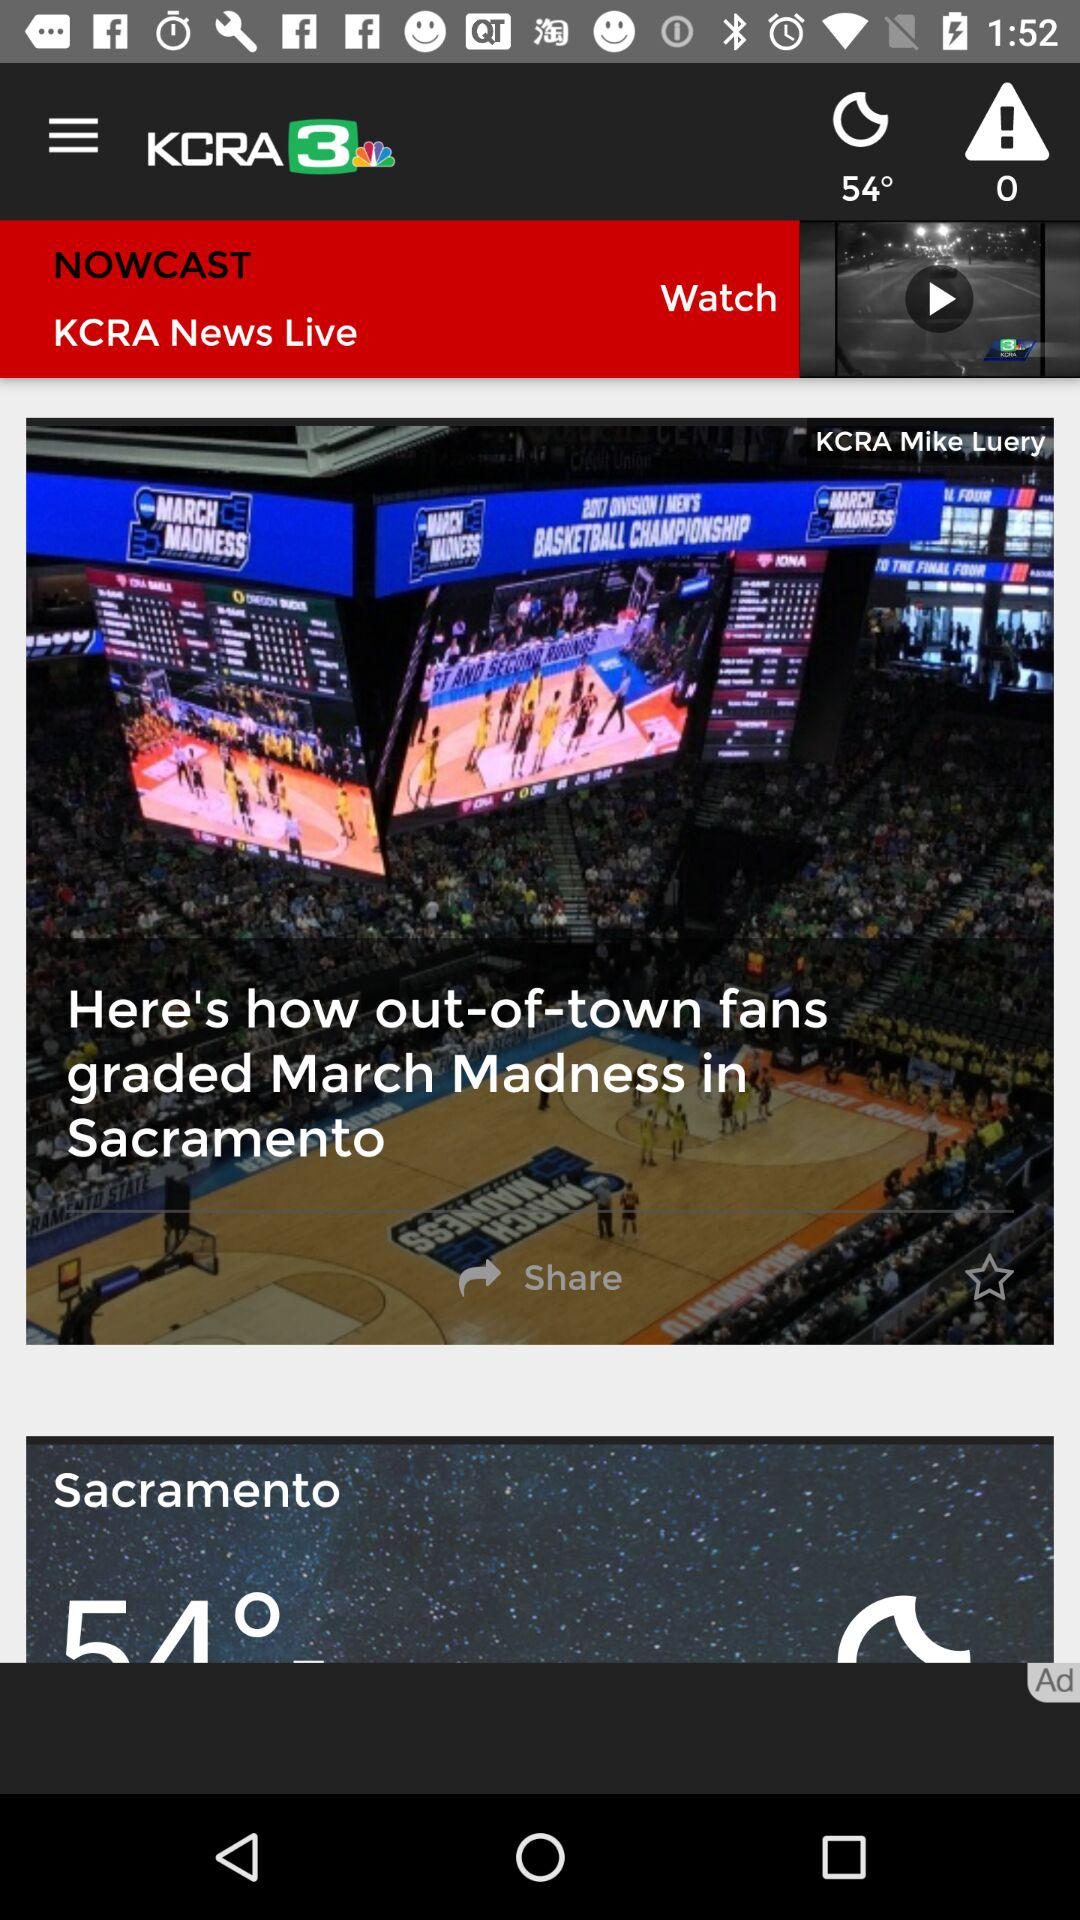What is the temperature in Sacramento? The temperature in Sacramento is 54°. 